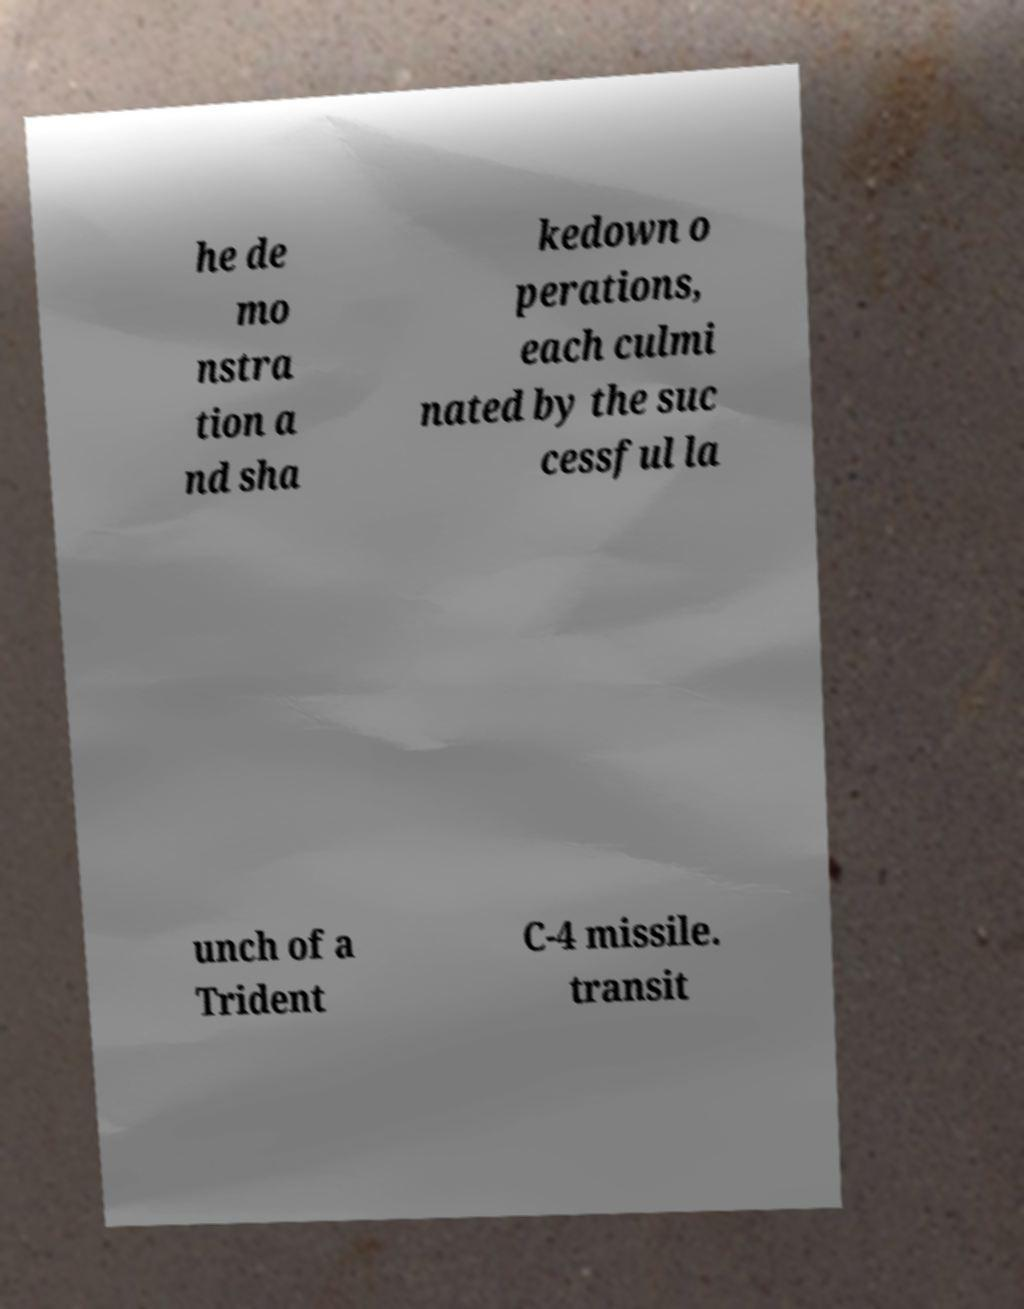Please identify and transcribe the text found in this image. he de mo nstra tion a nd sha kedown o perations, each culmi nated by the suc cessful la unch of a Trident C-4 missile. transit 